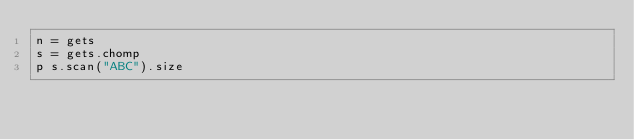<code> <loc_0><loc_0><loc_500><loc_500><_Ruby_>n = gets
s = gets.chomp
p s.scan("ABC").size</code> 